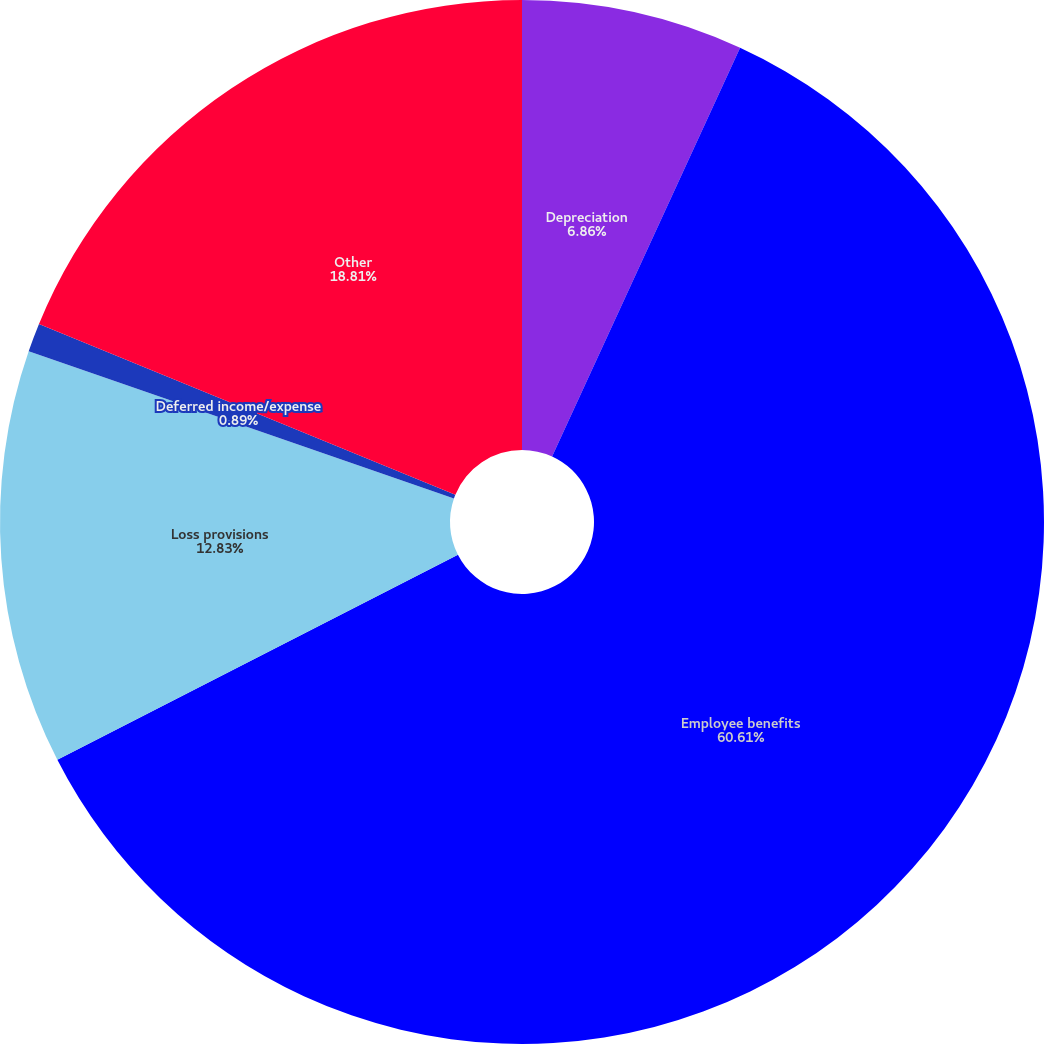Convert chart. <chart><loc_0><loc_0><loc_500><loc_500><pie_chart><fcel>Depreciation<fcel>Employee benefits<fcel>Loss provisions<fcel>Deferred income/expense<fcel>Other<nl><fcel>6.86%<fcel>60.61%<fcel>12.83%<fcel>0.89%<fcel>18.81%<nl></chart> 